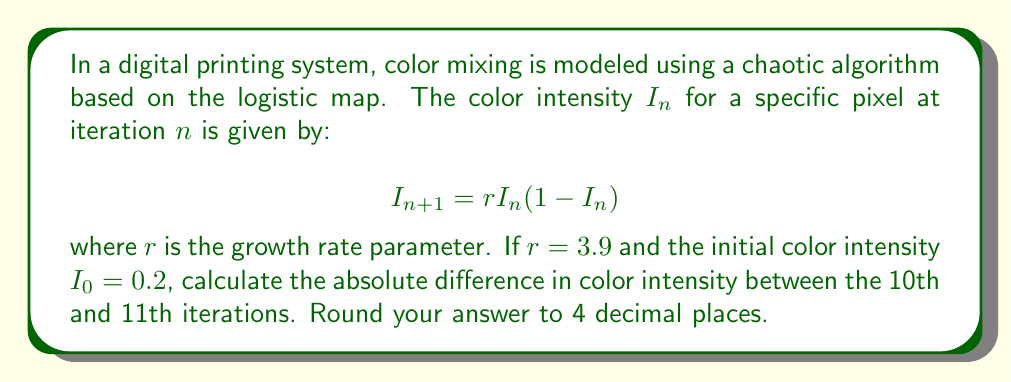Can you solve this math problem? To solve this problem, we need to iterate the logistic map equation for 11 steps and then compare the 10th and 11th values. Let's go through this step-by-step:

1) We start with $r = 3.9$ and $I_0 = 0.2$

2) For each iteration, we apply the formula $I_{n+1} = rI_n(1-I_n)$

3) Let's calculate the first 11 iterations:

   $I_1 = 3.9 * 0.2 * (1-0.2) = 0.624$
   $I_2 = 3.9 * 0.624 * (1-0.624) = 0.9165984$
   $I_3 = 3.9 * 0.9165984 * (1-0.9165984) = 0.3000253$
   $I_4 = 3.9 * 0.3000253 * (1-0.3000253) = 0.8190699$
   $I_5 = 3.9 * 0.8190699 * (1-0.8190699) = 0.5784131$
   $I_6 = 3.9 * 0.5784131 * (1-0.5784131) = 0.9499288$
   $I_7 = 3.9 * 0.9499288 * (1-0.9499288) = 0.1850112$
   $I_8 = 3.9 * 0.1850112 * (1-0.1850112) = 0.5878599$
   $I_9 = 3.9 * 0.5878599 * (1-0.5878599) = 0.9451360$
   $I_{10} = 3.9 * 0.9451360 * (1-0.9451360) = 0.2014909$
   $I_{11} = 3.9 * 0.2014909 * (1-0.2014909) = 0.6272846$

4) Now, we need to calculate the absolute difference between $I_{10}$ and $I_{11}$:

   $|I_{11} - I_{10}| = |0.6272846 - 0.2014909| = 0.4257937$

5) Rounding to 4 decimal places gives us 0.4258.

This demonstrates the butterfly effect in color mixing, where small changes in initial conditions (or iterative steps) can lead to significant differences in outcomes.
Answer: 0.4258 